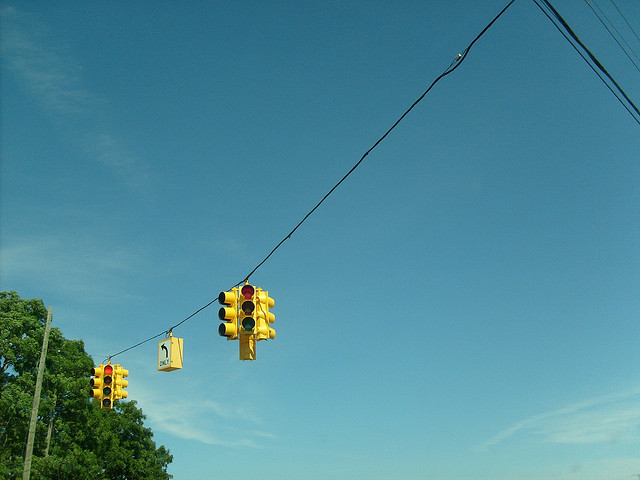Why are there so many lights? The presence of multiple traffic lights hanging from a wire over an intersection is typical in areas with complex traffic patterns or multiple lanes. This setup helps manage traffic flow more efficiently, ensuring that vehicles from various directions can navigate the intersection safely. 